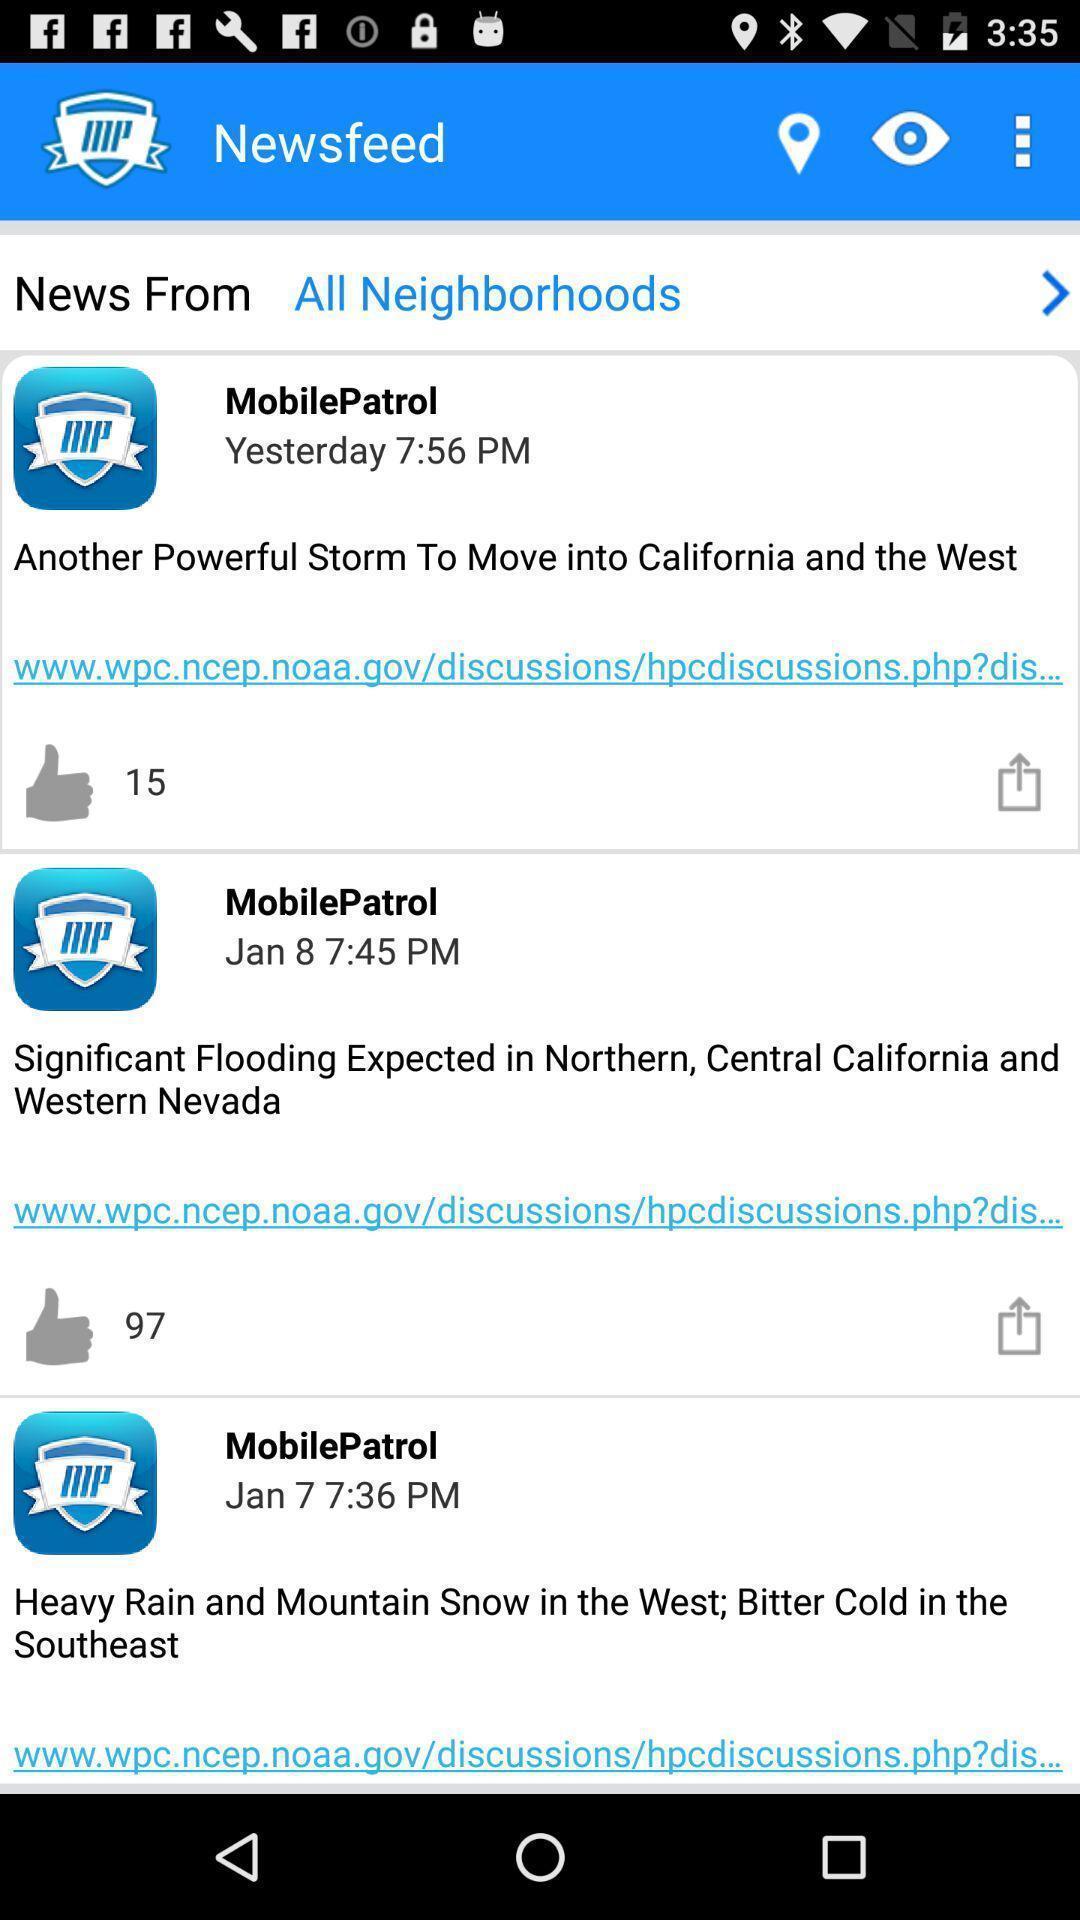Provide a textual representation of this image. Screen showing newsfeed. 